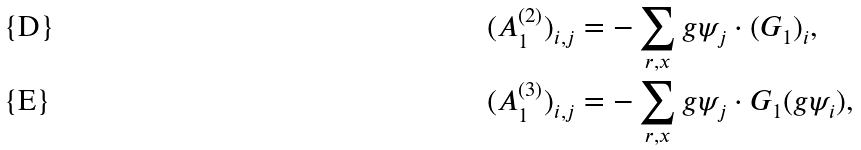<formula> <loc_0><loc_0><loc_500><loc_500>( A _ { 1 } ^ { ( 2 ) } ) _ { i , j } & = - \sum _ { r , x } g \psi _ { j } \cdot ( G _ { 1 } ) _ { i } , \\ ( A _ { 1 } ^ { ( 3 ) } ) _ { i , j } & = - \sum _ { r , x } g \psi _ { j } \cdot G _ { 1 } ( g \psi _ { i } ) ,</formula> 